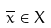<formula> <loc_0><loc_0><loc_500><loc_500>\overline { x } \in X</formula> 